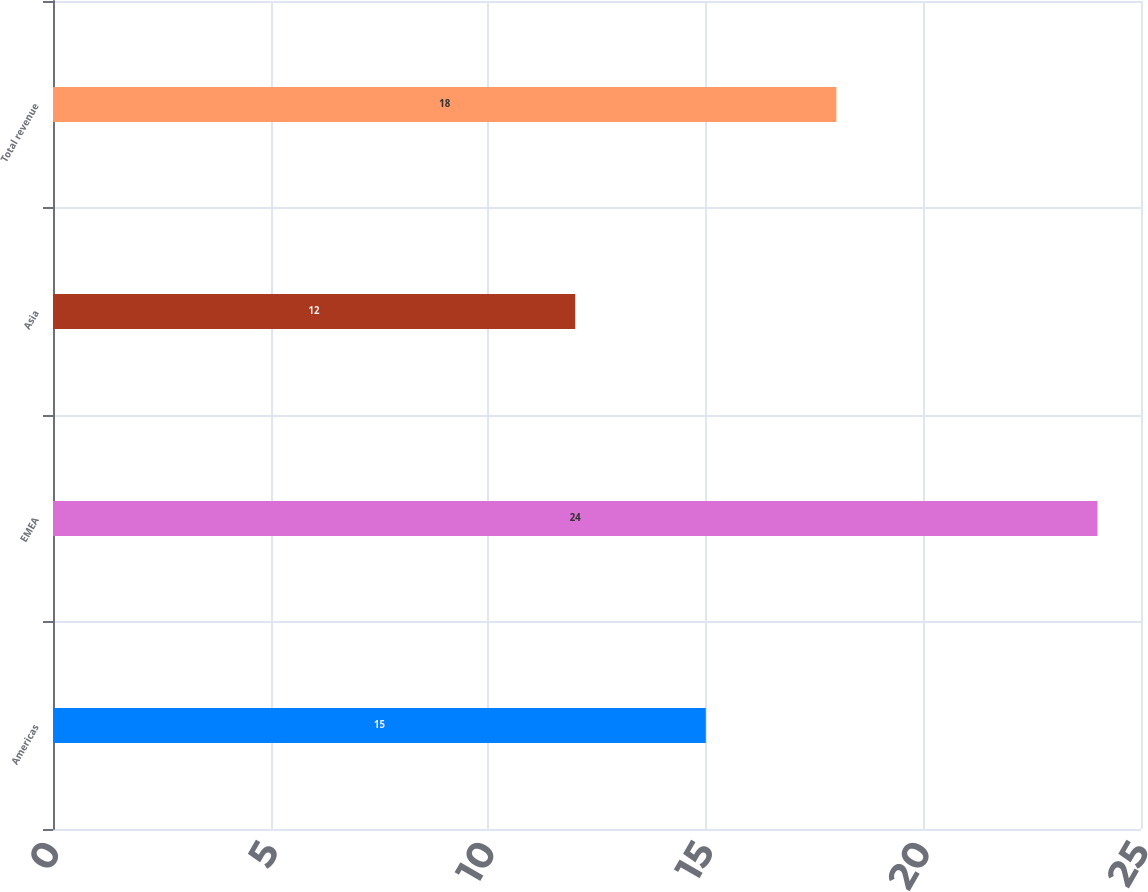<chart> <loc_0><loc_0><loc_500><loc_500><bar_chart><fcel>Americas<fcel>EMEA<fcel>Asia<fcel>Total revenue<nl><fcel>15<fcel>24<fcel>12<fcel>18<nl></chart> 